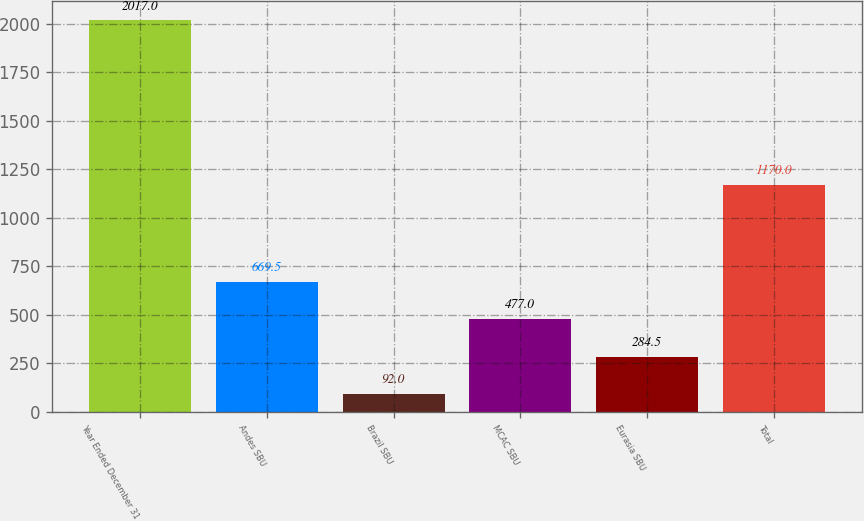<chart> <loc_0><loc_0><loc_500><loc_500><bar_chart><fcel>Year Ended December 31<fcel>Andes SBU<fcel>Brazil SBU<fcel>MCAC SBU<fcel>Eurasia SBU<fcel>Total<nl><fcel>2017<fcel>669.5<fcel>92<fcel>477<fcel>284.5<fcel>1170<nl></chart> 